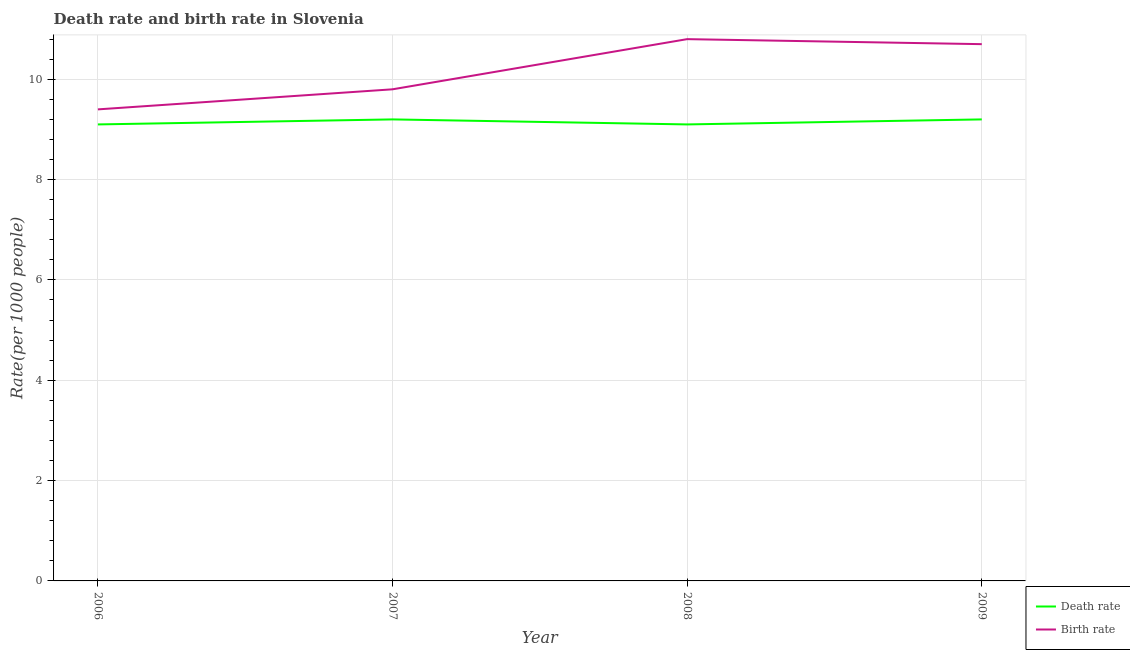How many different coloured lines are there?
Make the answer very short. 2. Does the line corresponding to birth rate intersect with the line corresponding to death rate?
Provide a succinct answer. No. Is the number of lines equal to the number of legend labels?
Make the answer very short. Yes. Across all years, what is the minimum death rate?
Your answer should be very brief. 9.1. What is the total birth rate in the graph?
Keep it short and to the point. 40.7. What is the difference between the birth rate in 2006 and that in 2009?
Provide a short and direct response. -1.3. What is the average death rate per year?
Your answer should be compact. 9.15. In the year 2008, what is the difference between the death rate and birth rate?
Make the answer very short. -1.7. What is the ratio of the death rate in 2008 to that in 2009?
Ensure brevity in your answer.  0.99. What is the difference between the highest and the second highest birth rate?
Provide a succinct answer. 0.1. What is the difference between the highest and the lowest death rate?
Give a very brief answer. 0.1. Does the death rate monotonically increase over the years?
Ensure brevity in your answer.  No. Is the birth rate strictly less than the death rate over the years?
Your answer should be very brief. No. How many years are there in the graph?
Your answer should be very brief. 4. How are the legend labels stacked?
Provide a succinct answer. Vertical. What is the title of the graph?
Provide a succinct answer. Death rate and birth rate in Slovenia. What is the label or title of the Y-axis?
Provide a short and direct response. Rate(per 1000 people). What is the Rate(per 1000 people) in Death rate in 2006?
Make the answer very short. 9.1. What is the Rate(per 1000 people) in Birth rate in 2007?
Offer a terse response. 9.8. What is the Rate(per 1000 people) of Death rate in 2008?
Make the answer very short. 9.1. What is the Rate(per 1000 people) of Death rate in 2009?
Keep it short and to the point. 9.2. What is the Rate(per 1000 people) in Birth rate in 2009?
Your answer should be very brief. 10.7. Across all years, what is the maximum Rate(per 1000 people) of Death rate?
Your answer should be very brief. 9.2. Across all years, what is the minimum Rate(per 1000 people) of Death rate?
Offer a very short reply. 9.1. Across all years, what is the minimum Rate(per 1000 people) in Birth rate?
Ensure brevity in your answer.  9.4. What is the total Rate(per 1000 people) in Death rate in the graph?
Offer a terse response. 36.6. What is the total Rate(per 1000 people) in Birth rate in the graph?
Ensure brevity in your answer.  40.7. What is the difference between the Rate(per 1000 people) of Birth rate in 2006 and that in 2007?
Keep it short and to the point. -0.4. What is the difference between the Rate(per 1000 people) of Death rate in 2006 and that in 2008?
Ensure brevity in your answer.  0. What is the difference between the Rate(per 1000 people) of Birth rate in 2006 and that in 2008?
Ensure brevity in your answer.  -1.4. What is the difference between the Rate(per 1000 people) of Death rate in 2007 and that in 2008?
Give a very brief answer. 0.1. What is the difference between the Rate(per 1000 people) of Death rate in 2008 and that in 2009?
Offer a very short reply. -0.1. What is the difference between the Rate(per 1000 people) in Birth rate in 2008 and that in 2009?
Your response must be concise. 0.1. What is the difference between the Rate(per 1000 people) in Death rate in 2007 and the Rate(per 1000 people) in Birth rate in 2008?
Offer a very short reply. -1.6. What is the difference between the Rate(per 1000 people) in Death rate in 2007 and the Rate(per 1000 people) in Birth rate in 2009?
Offer a terse response. -1.5. What is the average Rate(per 1000 people) in Death rate per year?
Offer a very short reply. 9.15. What is the average Rate(per 1000 people) in Birth rate per year?
Give a very brief answer. 10.18. In the year 2007, what is the difference between the Rate(per 1000 people) of Death rate and Rate(per 1000 people) of Birth rate?
Your response must be concise. -0.6. In the year 2009, what is the difference between the Rate(per 1000 people) of Death rate and Rate(per 1000 people) of Birth rate?
Ensure brevity in your answer.  -1.5. What is the ratio of the Rate(per 1000 people) in Death rate in 2006 to that in 2007?
Your response must be concise. 0.99. What is the ratio of the Rate(per 1000 people) of Birth rate in 2006 to that in 2007?
Your response must be concise. 0.96. What is the ratio of the Rate(per 1000 people) in Birth rate in 2006 to that in 2008?
Offer a terse response. 0.87. What is the ratio of the Rate(per 1000 people) in Birth rate in 2006 to that in 2009?
Provide a succinct answer. 0.88. What is the ratio of the Rate(per 1000 people) in Death rate in 2007 to that in 2008?
Offer a very short reply. 1.01. What is the ratio of the Rate(per 1000 people) of Birth rate in 2007 to that in 2008?
Your answer should be very brief. 0.91. What is the ratio of the Rate(per 1000 people) of Birth rate in 2007 to that in 2009?
Offer a very short reply. 0.92. What is the ratio of the Rate(per 1000 people) of Death rate in 2008 to that in 2009?
Provide a short and direct response. 0.99. What is the ratio of the Rate(per 1000 people) in Birth rate in 2008 to that in 2009?
Offer a very short reply. 1.01. What is the difference between the highest and the lowest Rate(per 1000 people) in Birth rate?
Keep it short and to the point. 1.4. 